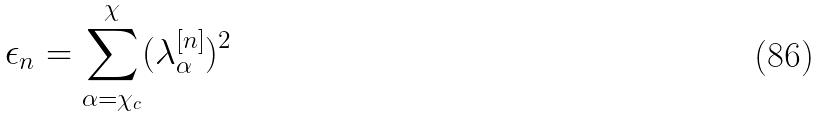Convert formula to latex. <formula><loc_0><loc_0><loc_500><loc_500>\epsilon _ { n } = \sum _ { \alpha = \chi _ { c } } ^ { \chi } ( \lambda _ { \alpha } ^ { [ n ] } ) ^ { 2 }</formula> 